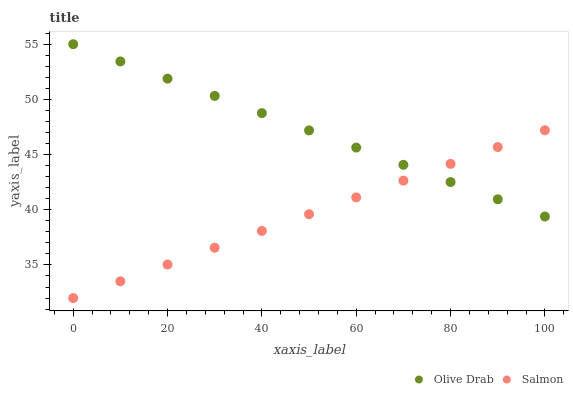Does Salmon have the minimum area under the curve?
Answer yes or no. Yes. Does Olive Drab have the maximum area under the curve?
Answer yes or no. Yes. Does Olive Drab have the minimum area under the curve?
Answer yes or no. No. Is Olive Drab the smoothest?
Answer yes or no. Yes. Is Salmon the roughest?
Answer yes or no. Yes. Is Olive Drab the roughest?
Answer yes or no. No. Does Salmon have the lowest value?
Answer yes or no. Yes. Does Olive Drab have the lowest value?
Answer yes or no. No. Does Olive Drab have the highest value?
Answer yes or no. Yes. Does Salmon intersect Olive Drab?
Answer yes or no. Yes. Is Salmon less than Olive Drab?
Answer yes or no. No. Is Salmon greater than Olive Drab?
Answer yes or no. No. 